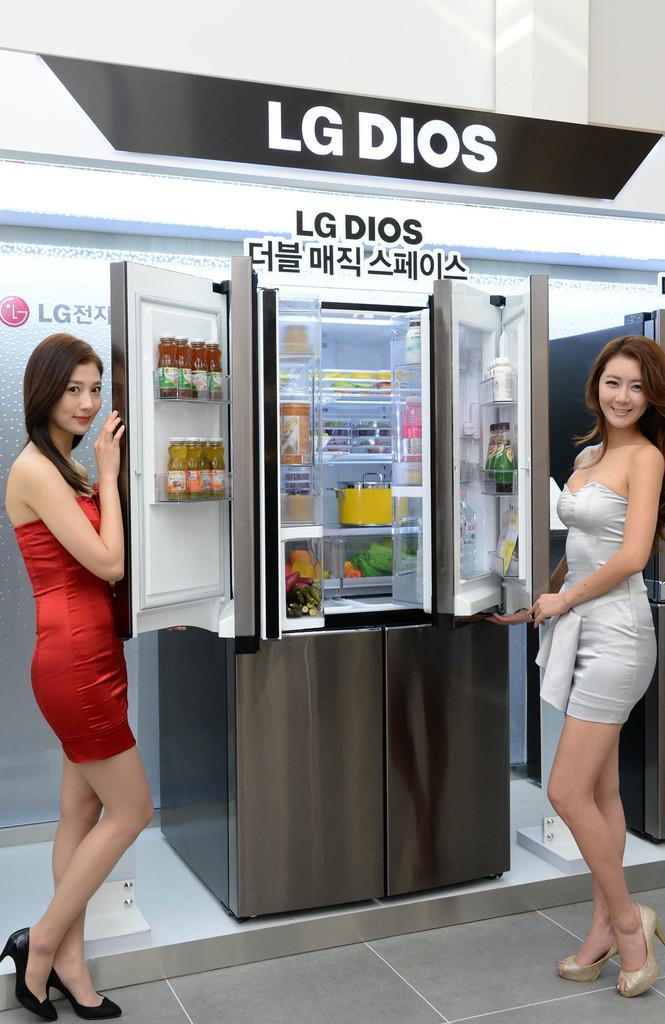<image>
Offer a succinct explanation of the picture presented. Two women showcase a stainless steel LG Dios refrigerator. 